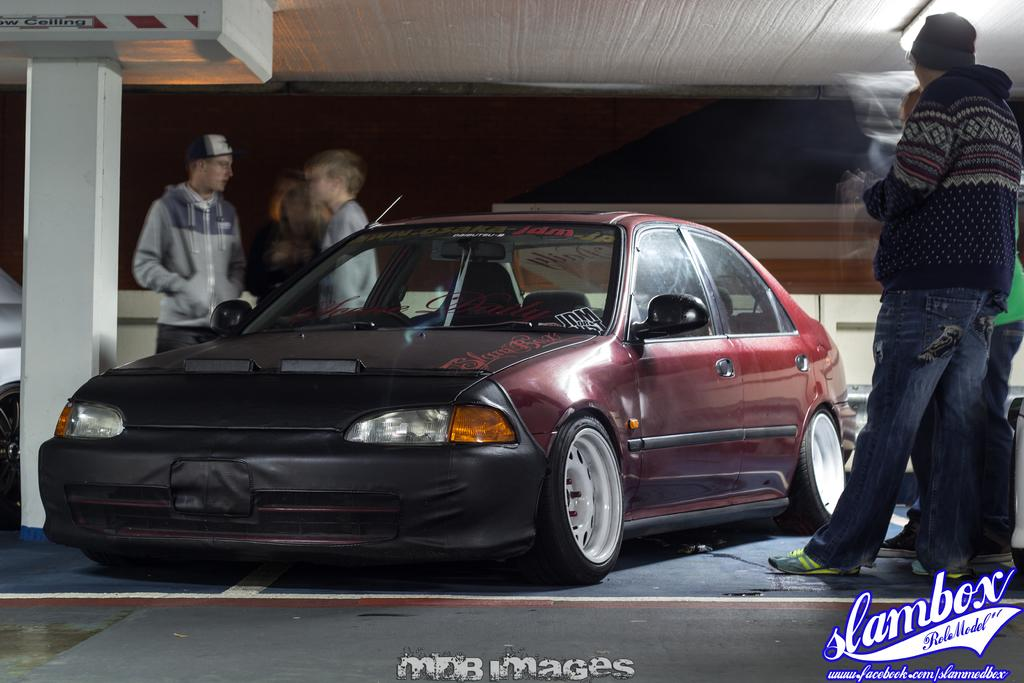What is the main subject of the image? The main subject of the image is a car. Can you describe the car in the image? The car is red and has tyres, headlights, windows, doors, and mirrors. Are there any people in the image? Yes, there are people standing on both the left and right sides of the image. What type of church can be seen in the image? There is no church present in the image; it features a red car and people standing on both sides. How many snakes are visible in the image? There are no snakes present in the image. 